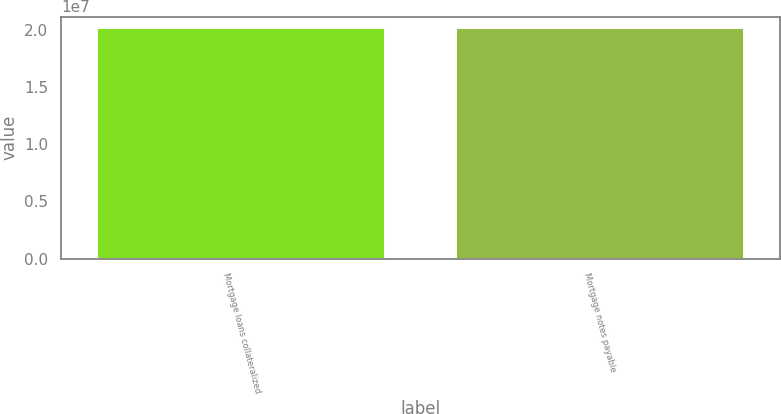Convert chart to OTSL. <chart><loc_0><loc_0><loc_500><loc_500><bar_chart><fcel>Mortgage loans collateralized<fcel>Mortgage notes payable<nl><fcel>2.0122e+07<fcel>2.0142e+07<nl></chart> 